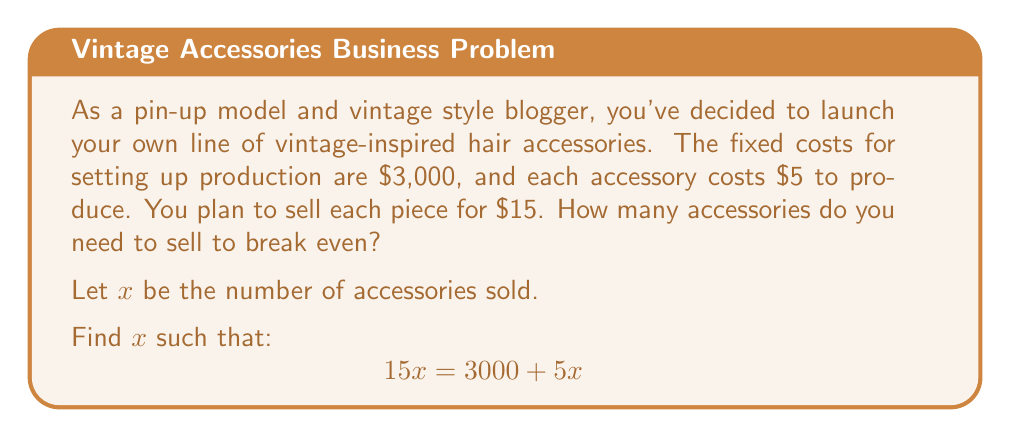Give your solution to this math problem. To find the break-even point, we need to determine the number of units where total revenue equals total costs.

1. Set up the equation:
   Total Revenue = Total Costs
   $$ 15x = 3000 + 5x $$

2. Subtract $5x$ from both sides:
   $$ 10x = 3000 $$

3. Divide both sides by 10:
   $$ x = 300 $$

4. Interpret the result:
   The break-even point occurs when 300 accessories are sold.

To verify:
- Revenue: $15 \times 300 = $4,500
- Costs: $3,000 + ($5 \times 300) = $4,500

At 300 units, revenue equals costs, confirming the break-even point.
Answer: The break-even point is 300 accessories. 